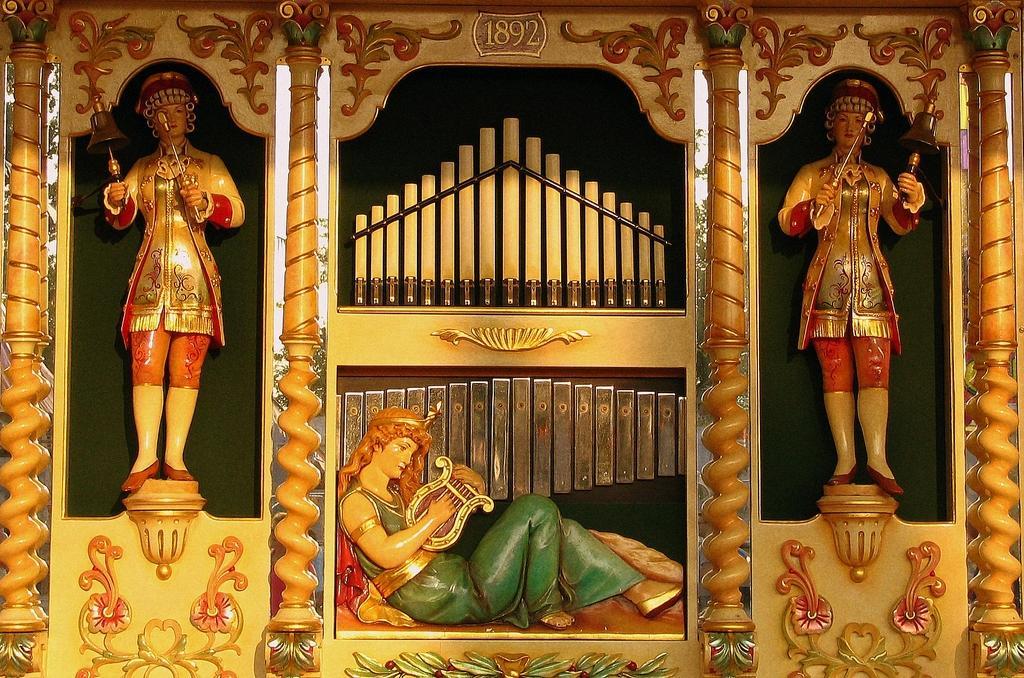Please provide a concise description of this image. These are the sculptures, in the middle it is in the shape of a woman. 